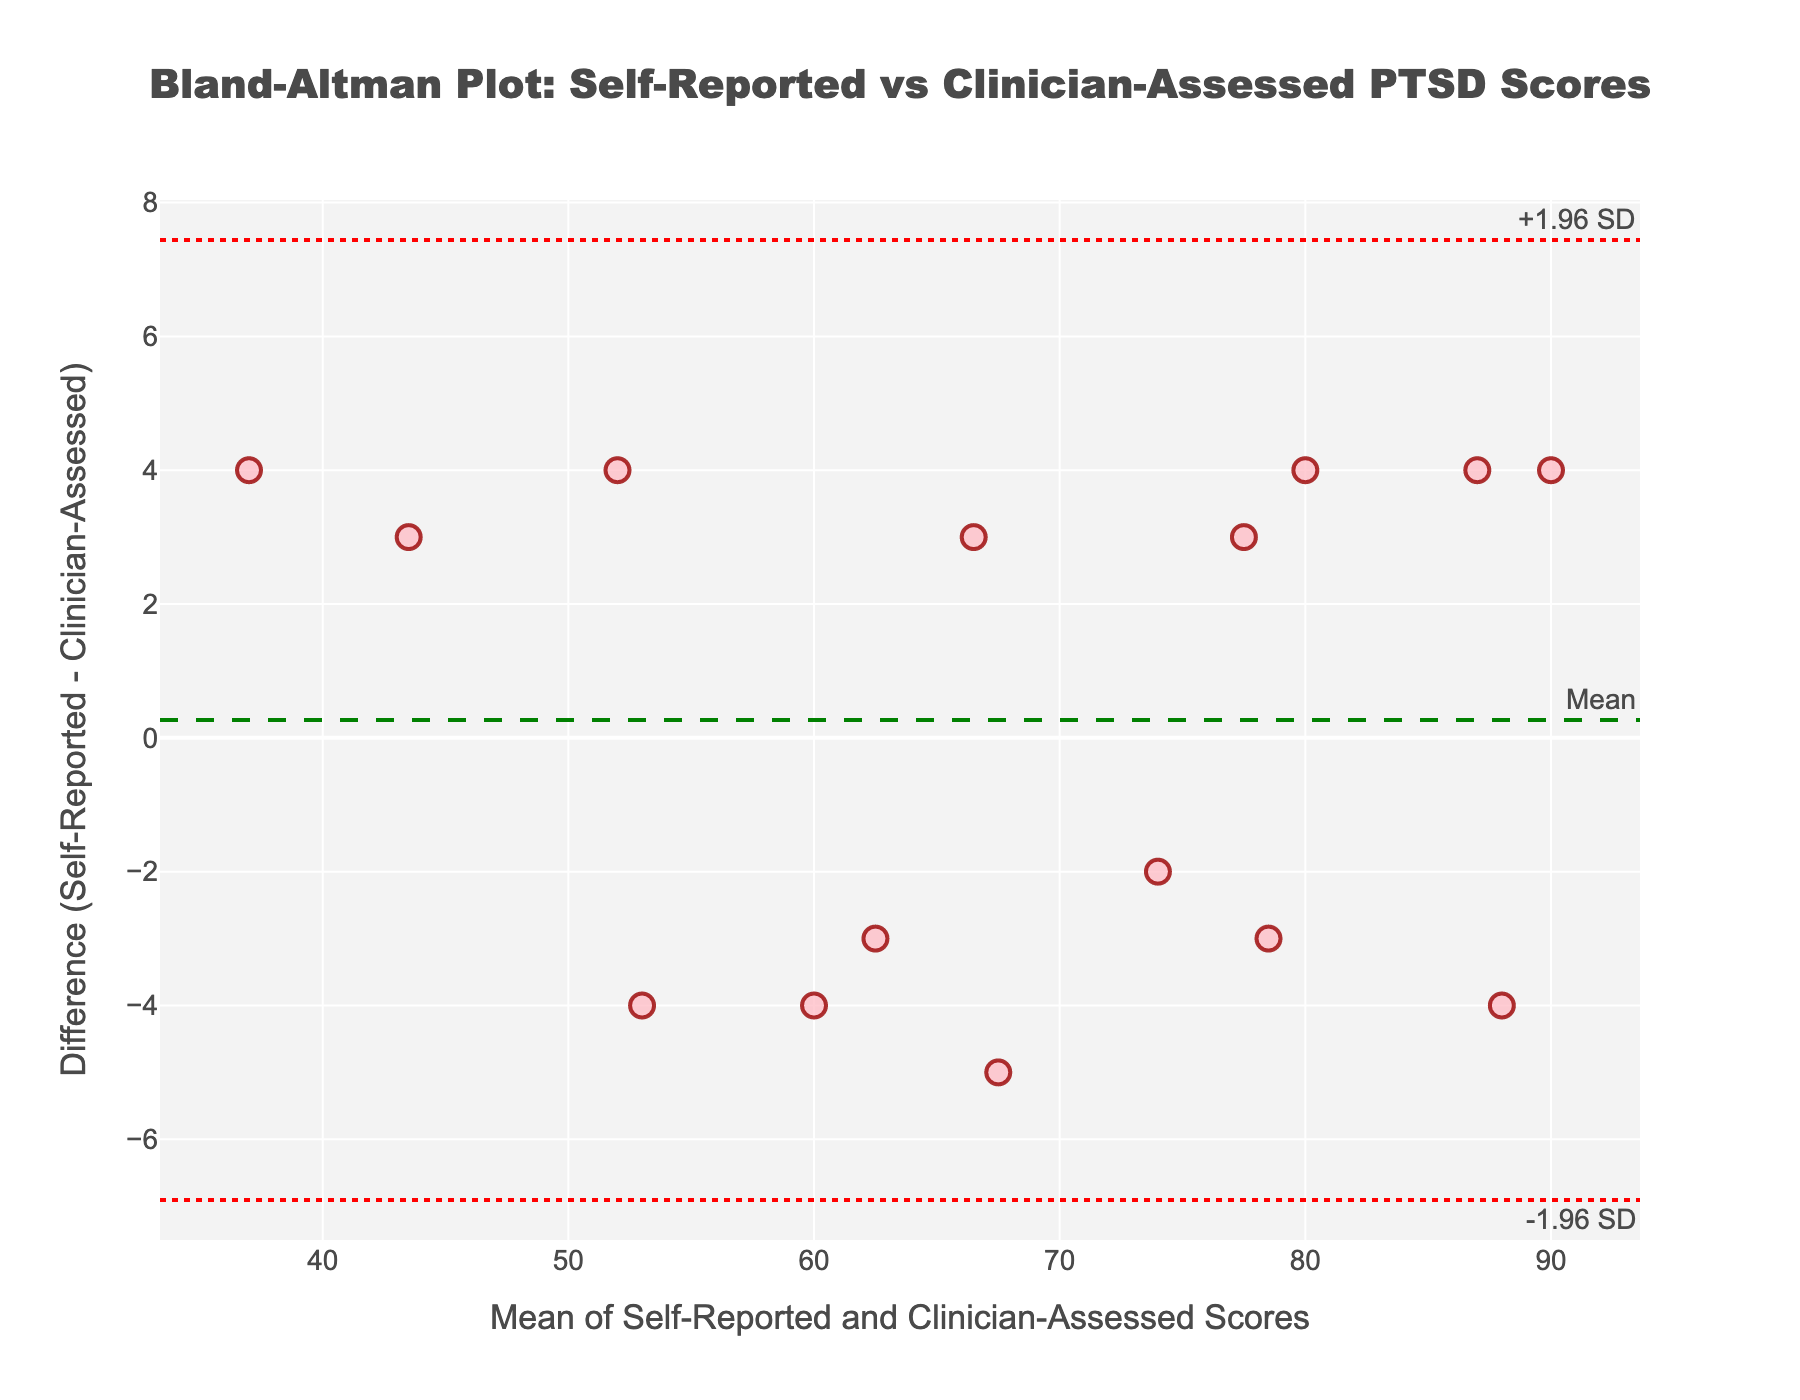What does the title of the figure say? The title is located at the top of the figure and provides context on what the plot represents. It reads "Bland-Altman Plot: Self-Reported vs Clinician-Assessed PTSD Scores".
Answer: Bland-Altman Plot: Self-Reported vs Clinician-Assessed PTSD Scores How many data points are displayed in the plot? By counting the number of markers on the plot, we can see there are 15 data points, representing 15 subjects.
Answer: 15 What is the x-axis title of the figure? The x-axis title is located along the horizontal axis and describes what the x-values represent. It says "Mean of Self-Reported and Clinician-Assessed Scores".
Answer: Mean of Self-Reported and Clinician-Assessed Scores What is the y-axis title of the figure? The y-axis title is located along the vertical axis and it describes the y-values. It reads "Difference (Self-Reported - Clinician-Assessed)".
Answer: Difference (Self-Reported - Clinician-Assessed) What color and size are the data points in the plot? The data points in the plot are colored in a shade of pink with a size of 12 as observed from the visual representation.
Answer: Pink, size 12 What are the upper and lower limits of agreement in the figure? The plot includes lines for the upper and lower limits of agreement, which are noted as "+1.96 SD" and "-1.96 SD" respectively. By observing where the horizontal red dotted lines intersect the y-axis, they represent these values. The exact numerical values are located beside these lines on the y-axis.
Answer: Upper: +1.96 SD, Lower: -1.96 SD What is the mean difference between Self-Reported and Clinician-Assessed PTSD Scores? The mean difference is indicated by a green dashed line on the plot. The numerical value is provided in an annotation next to the green dashed line.
Answer: Mean difference Is there a general trend observed in the differences between Self-Reported and Clinician-Assessed PTSD scores relative to their mean? By looking at the differences (y-values) across the mean of the scores (x-values), we see if differences are clustered around the mean difference line or diverge systematically.
Answer: General trend Which subject shows the highest positive difference between Self-Reported and Clinician-Assessed scores? By identifying the highest data point above the mean difference line and seeing which subject it corresponds to, we determine the highest positive difference.
Answer: Subject with highest positive difference Who are the subjects with differences that exceed the limits of agreement? Subjects with differences exceeding the red dotted lines, both above and below the mean difference line, are identified. These are outliers in agreement.
Answer: Subjects exceeding limits of agreement 